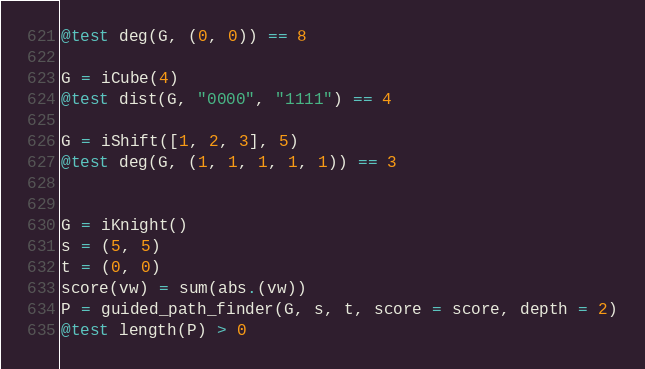<code> <loc_0><loc_0><loc_500><loc_500><_Julia_>@test deg(G, (0, 0)) == 8

G = iCube(4)
@test dist(G, "0000", "1111") == 4

G = iShift([1, 2, 3], 5)
@test deg(G, (1, 1, 1, 1, 1)) == 3


G = iKnight()
s = (5, 5)
t = (0, 0)
score(vw) = sum(abs.(vw))
P = guided_path_finder(G, s, t, score = score, depth = 2)
@test length(P) > 0
</code> 